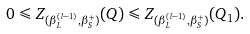<formula> <loc_0><loc_0><loc_500><loc_500>0 \leqslant Z _ { ( \beta ^ { ( l - 1 ) } _ { L } , \beta ^ { + } _ { S } ) } ( Q ) \leqslant Z _ { ( \beta ^ { ( l - 1 ) } _ { L } , \beta ^ { + } _ { S } ) } ( Q _ { 1 } ) .</formula> 